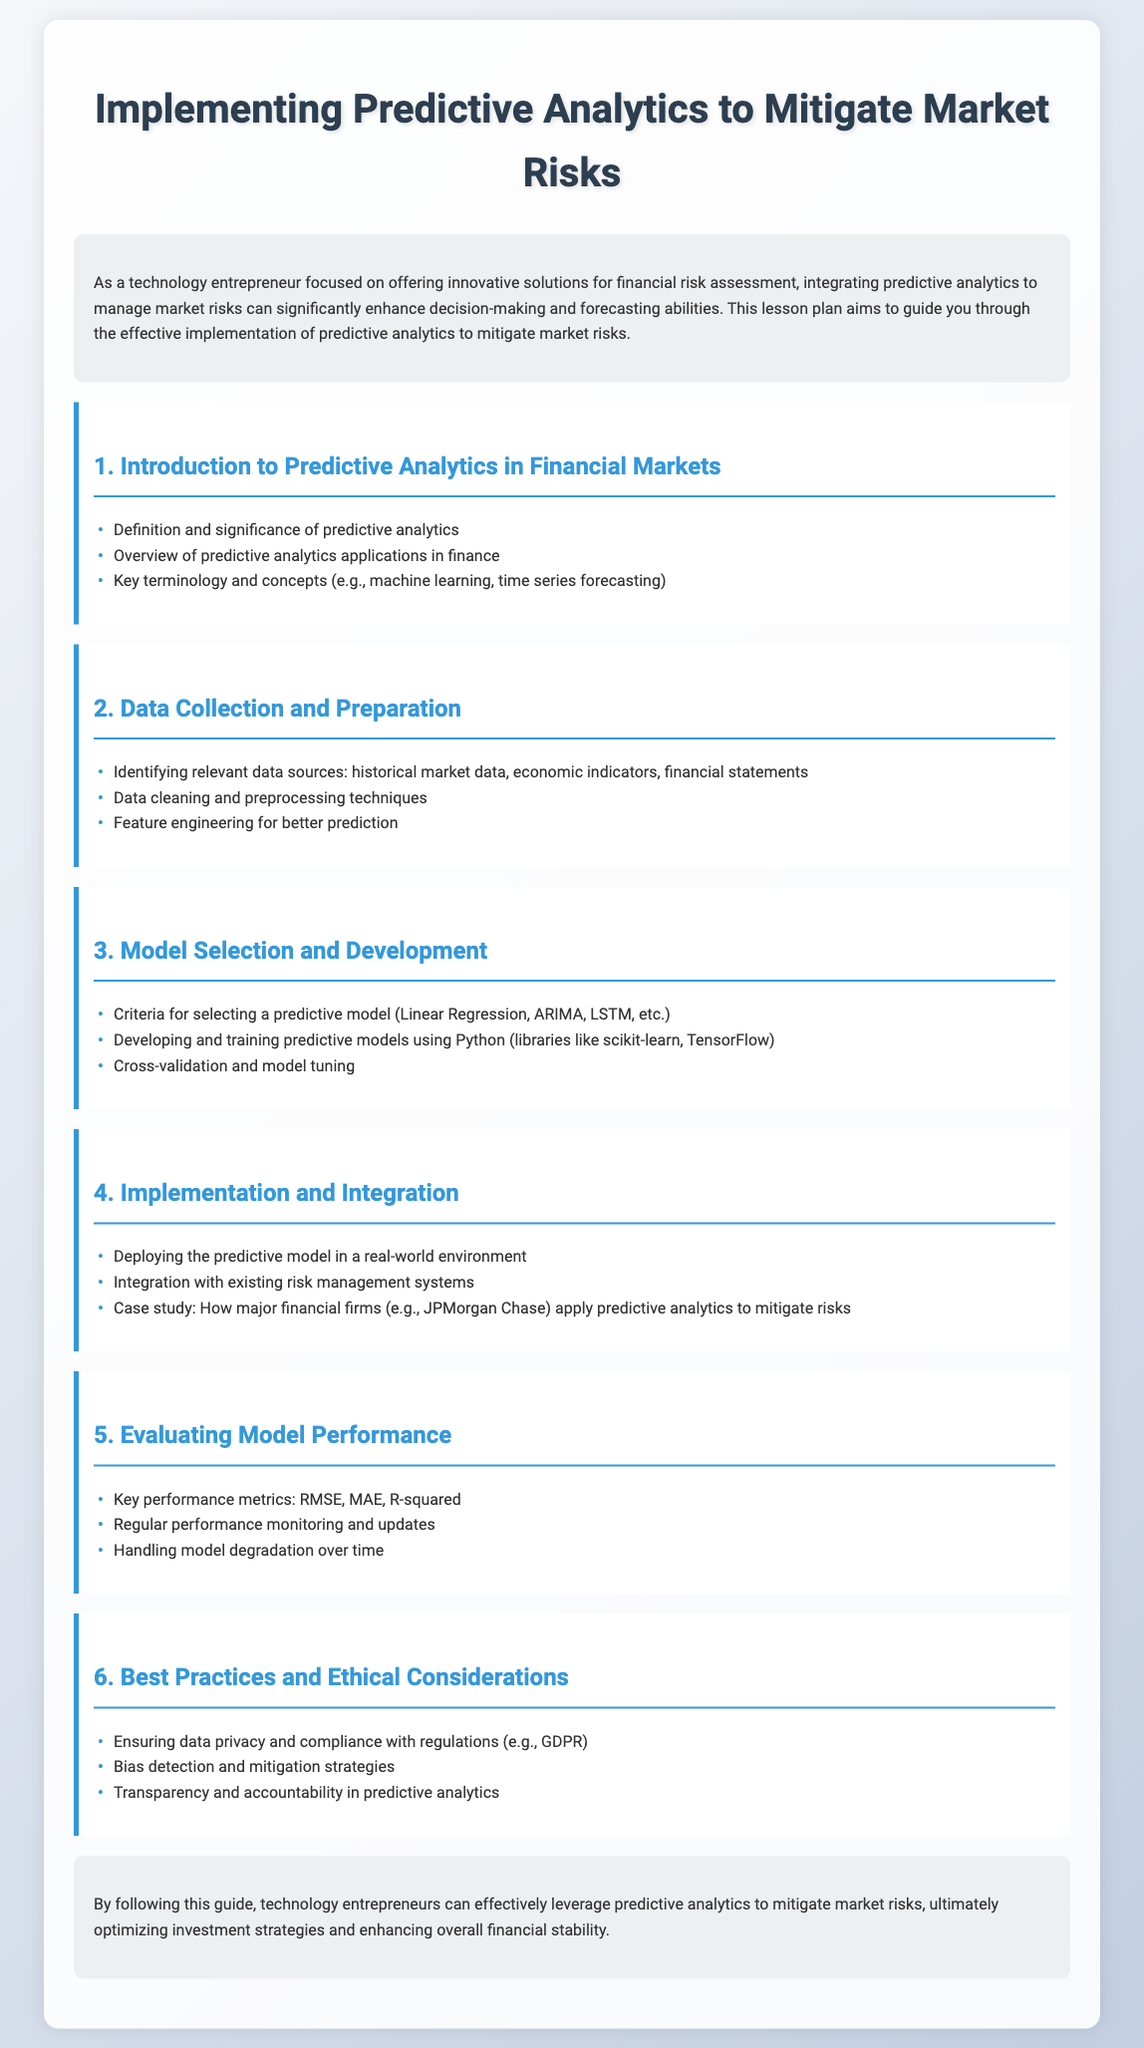What is the title of the lesson plan? The title of the lesson plan is prominently displayed at the top of the document.
Answer: Implementing Predictive Analytics to Mitigate Market Risks What are the first three modules listed in the lesson plan? The modules are detailed in separate sections with headings and list items.
Answer: Introduction to Predictive Analytics in Financial Markets, Data Collection and Preparation, Model Selection and Development Which library is mentioned for developing predictive models? The document specifies Python libraries that are commonly used in model development.
Answer: scikit-learn What is one of the key performance metrics for evaluating model performance? Performance metrics are listed in the module dedicated to model evaluation.
Answer: RMSE What is a focus of the best practices module? The best practices module outlines various considerations relevant to implementing predictive analytics.
Answer: Data privacy and compliance with regulations How does the lesson plan conclude? The conclusion summarizes the benefits and applications of the discussed methods.
Answer: Leverage predictive analytics to mitigate market risks 